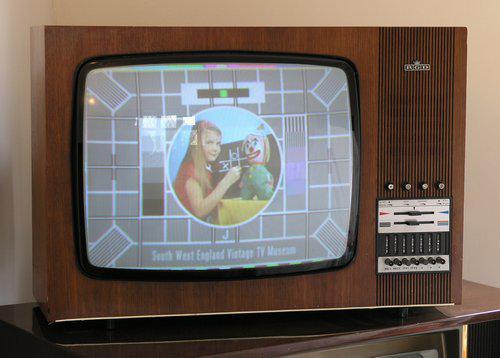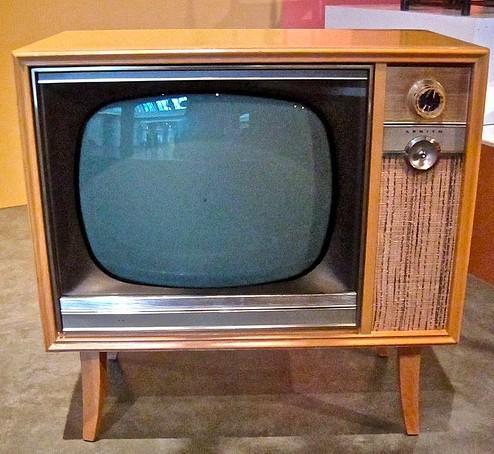The first image is the image on the left, the second image is the image on the right. Assess this claim about the two images: "An image shows a TV screen displaying a pattern of squares with a circle in the center.". Correct or not? Answer yes or no. Yes. The first image is the image on the left, the second image is the image on the right. Given the left and right images, does the statement "One television set is a table top model, while the other is standing on legs, but both have a control and speaker area to the side of the picture tube." hold true? Answer yes or no. Yes. 